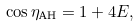<formula> <loc_0><loc_0><loc_500><loc_500>\cos \eta _ { \text {AH} } = 1 + 4 E ,</formula> 